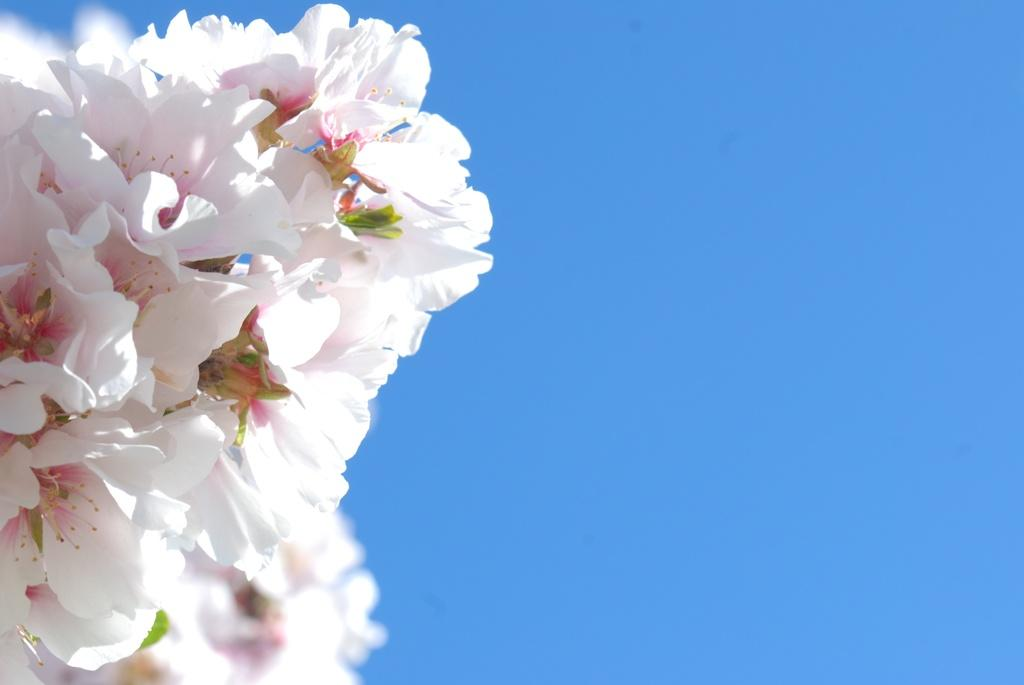What type of flowers are in the picture? There is a bunch of white flowers in the picture. What color is the background of the picture? The background of the picture is blue. How many people are in the crowd in the picture? There is no crowd present in the picture; it only features a bunch of white flowers against a blue background. 